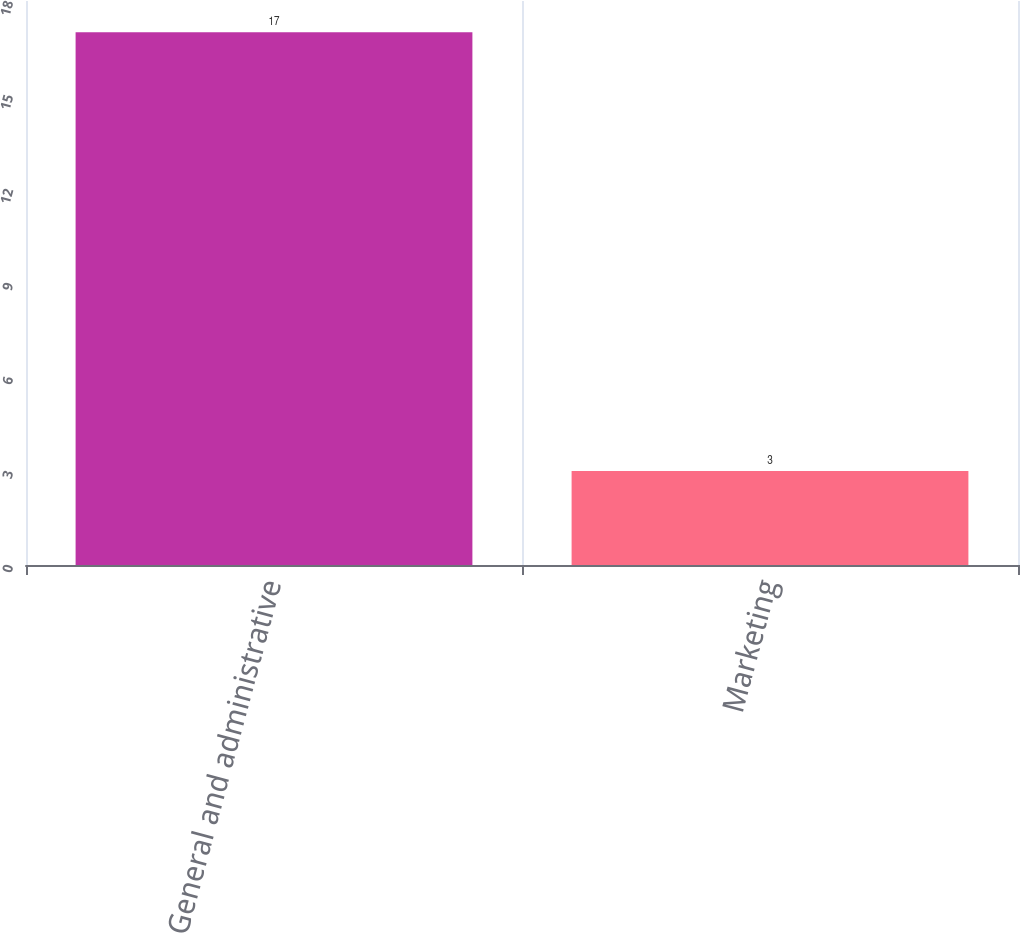Convert chart. <chart><loc_0><loc_0><loc_500><loc_500><bar_chart><fcel>General and administrative<fcel>Marketing<nl><fcel>17<fcel>3<nl></chart> 